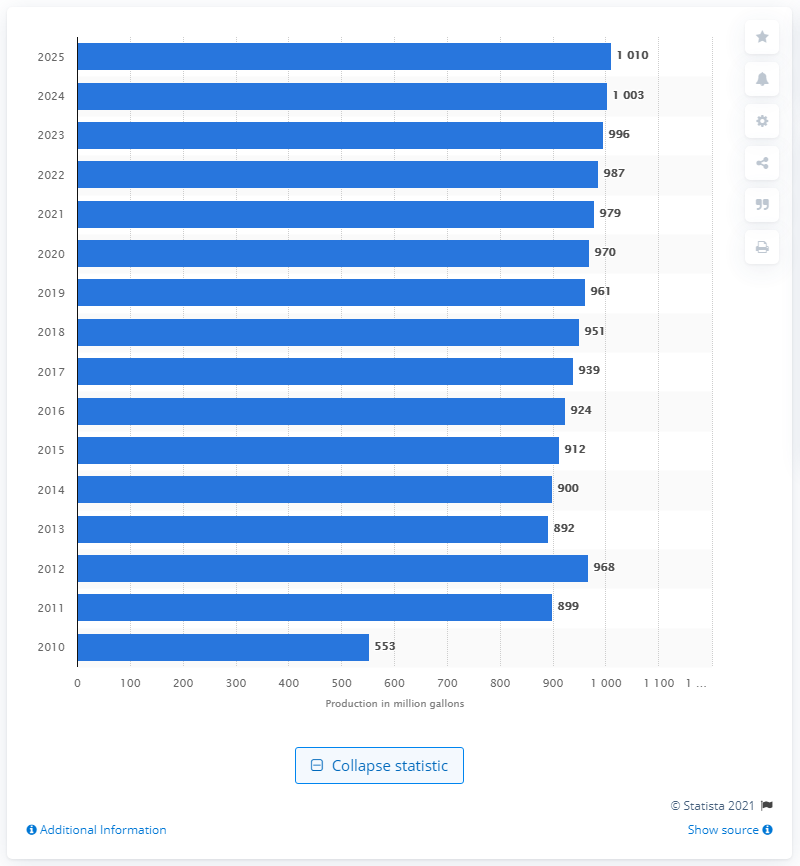Identify some key points in this picture. The projected production of biodiesel in the United States for the year 2025 is expected to be approximately 1010 metric tons. 